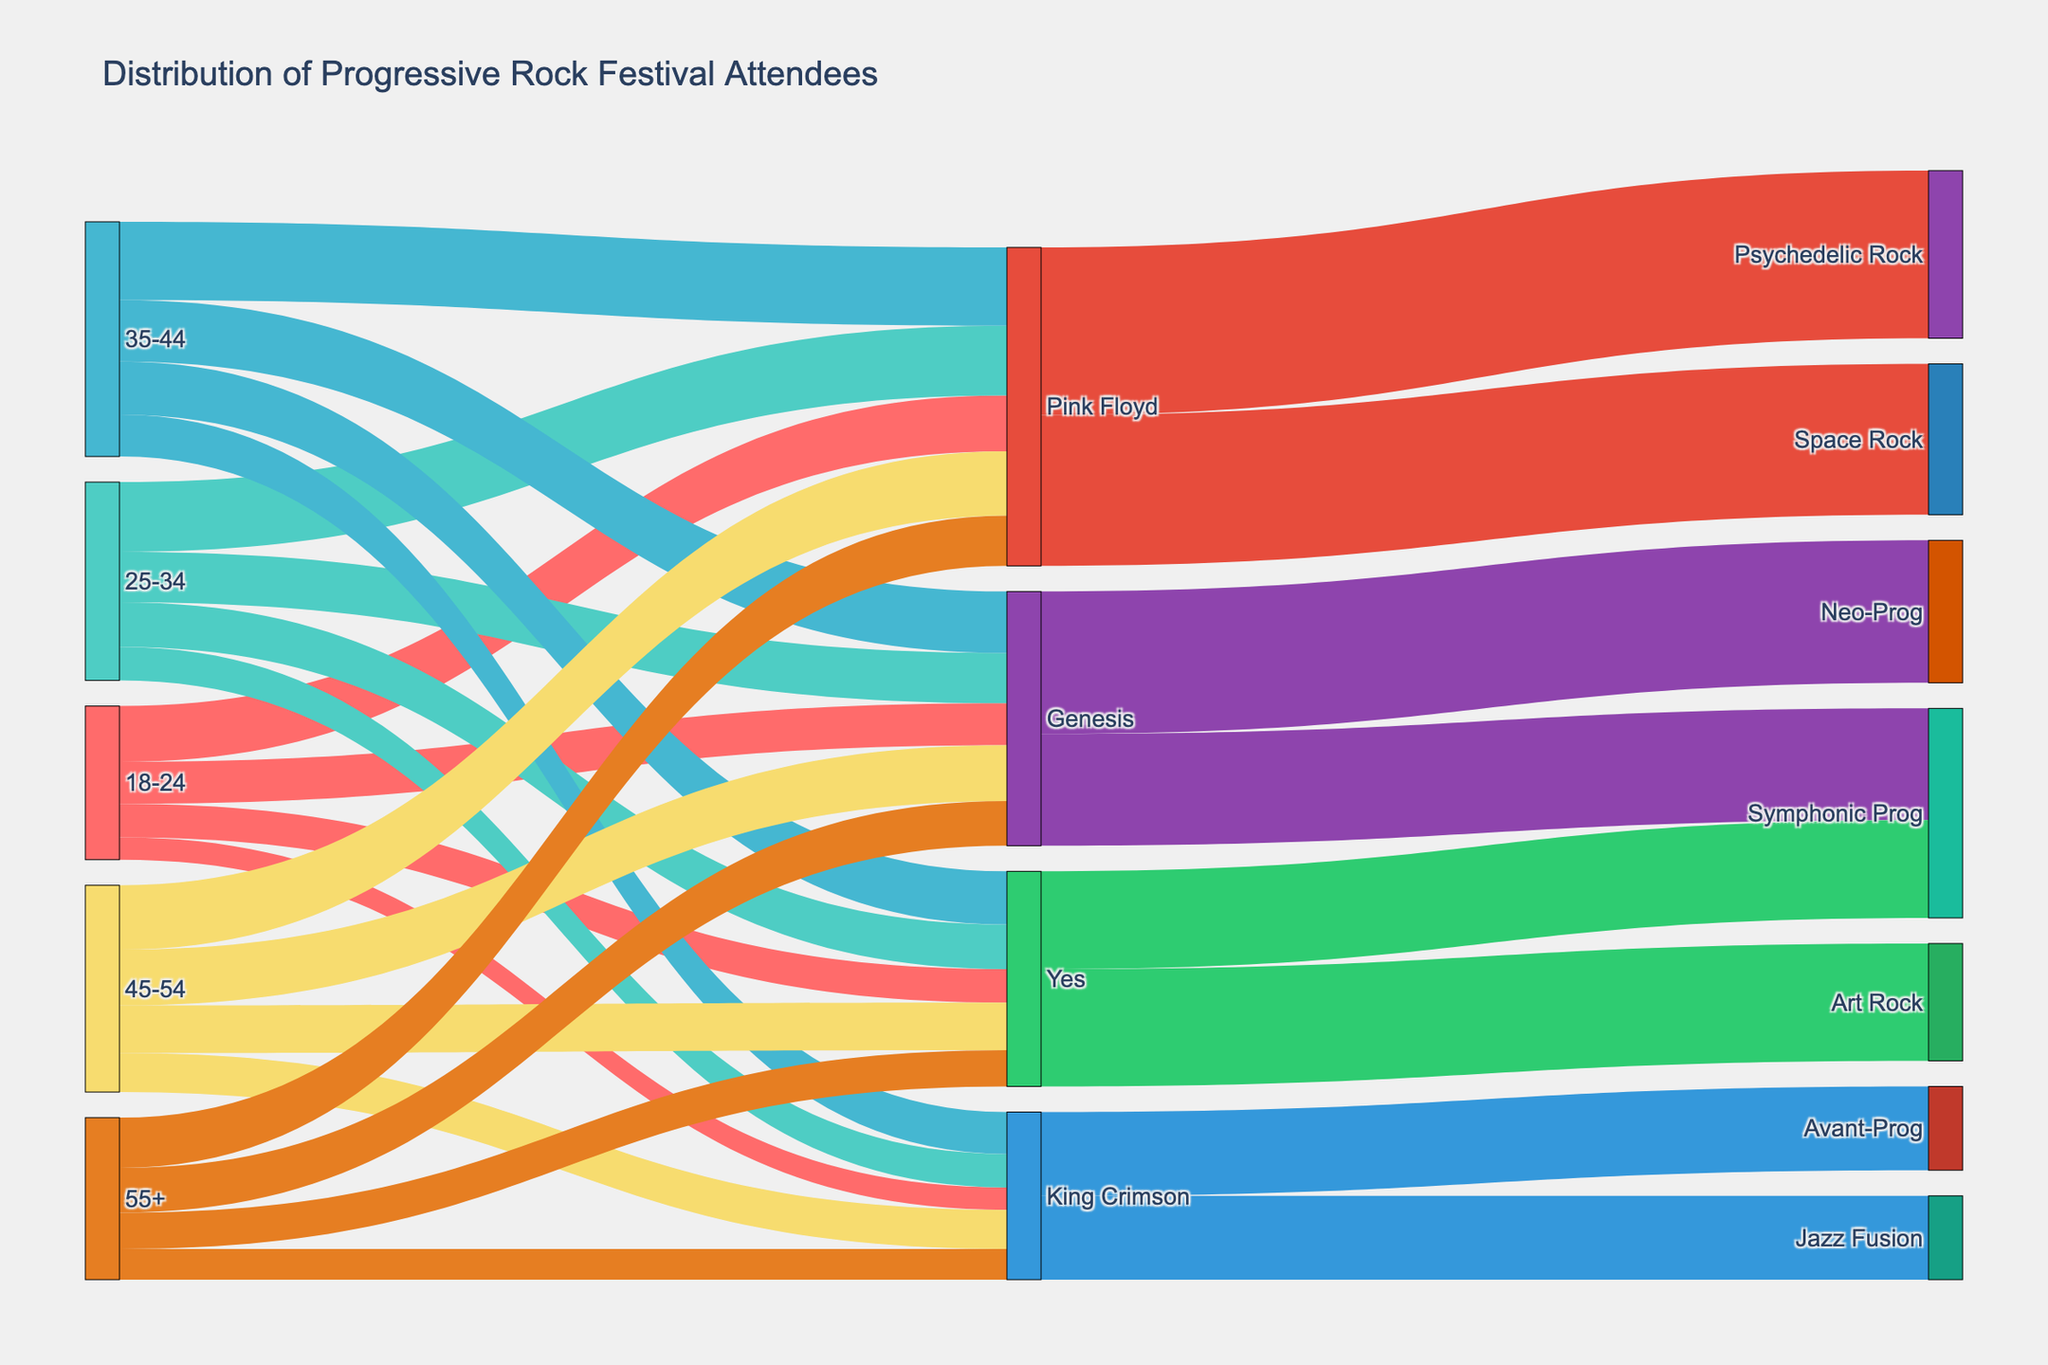What's the most popular band among the 18-24 age group? Look at the sections connecting the 18-24 age group to the bands. The sections are labeled with values, and Pink Floyd has the largest value.
Answer: Pink Floyd How many attendees aged 25-34 prefer King Crimson? Find the section connecting the 25-34 age group to King Crimson and note the value.
Answer: 120 Which musical genre has the most attendees who prefer Genesis? Look at the sections connecting Genesis to musical genres and find the one with the largest value.
Answer: Neo-Prog What is the total number of attendees aged 45-54? Sum the values connected to the 45-54 age group: 200 (Genesis) + 170 (Yes) + 230 (Pink Floyd) + 140 (King Crimson).
Answer: 740 Which musical genre is least popular among King Crimson fans? Look at the sections connecting King Crimson to musical genres and identify the one with the smallest value. Both sections have equal values.
Answer: Avant-Prog, Jazz Fusion Compare the number of Pink Floyd fans in the 35-44 age group to those in the 55+ age group. Find the sections connecting Pink Floyd to the 35-44 and 55+ age groups and compare their values: 280 (35-44) and 180 (55+).
Answer: 35-44 > 55+ Between Genesis and Yes, which band has more fans across all age groups? Sum the values connected to Genesis and Yes across all age groups: Genesis (150 + 180 + 220 + 200 + 160), Yes (120 + 160 + 190 + 170 + 130).
Answer: Genesis How does the popularity of Symphonic Prog compare between fans of Genesis and Yes? Look at the sections connecting Symphonic Prog to Genesis and Yes and compare their values: 400 (Genesis) and 350 (Yes).
Answer: Genesis > Yes What percentage of Pink Floyd fans prefer Psychedelic Rock? Calculate the proportion of Pink Floyd fans who prefer Psychedelic Rock by dividing the number of Psychedelic Rock fans (600) by the total number of Pink Floyd fans (600 + 540) and multiply by 100.
Answer: 52.6% 